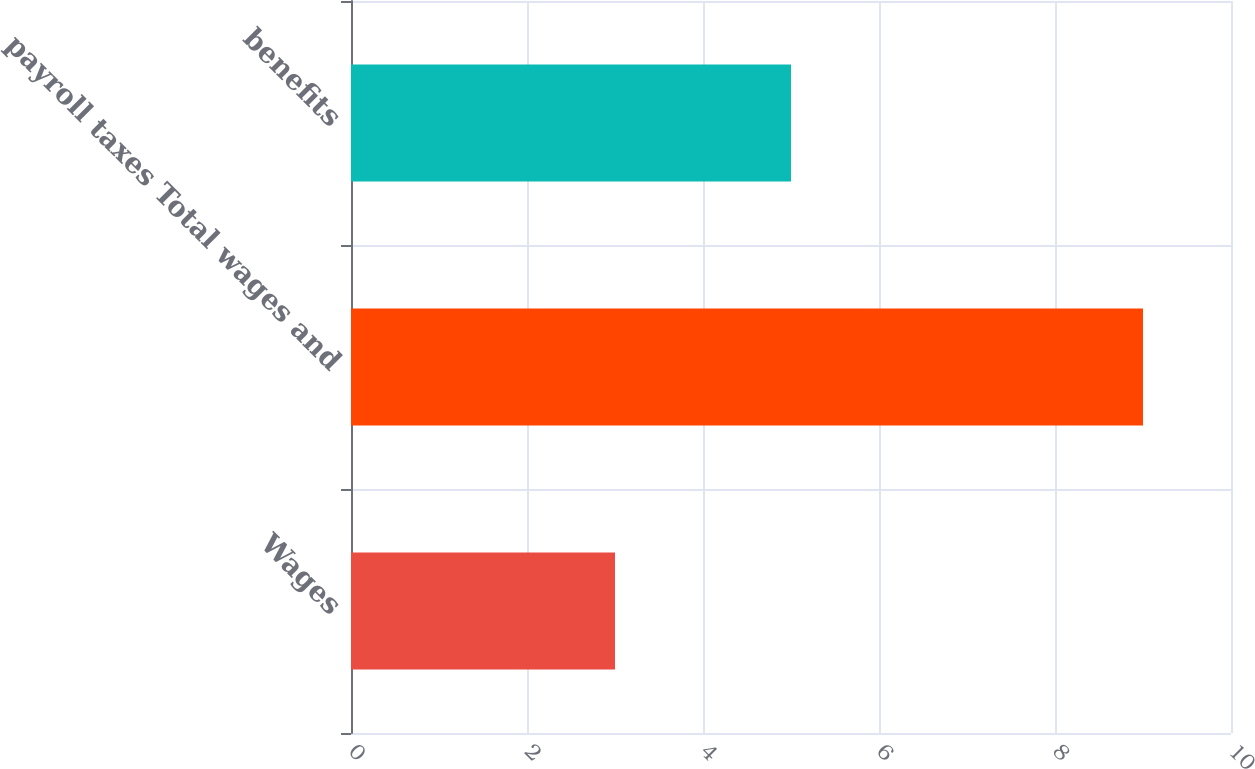<chart> <loc_0><loc_0><loc_500><loc_500><bar_chart><fcel>Wages<fcel>payroll taxes Total wages and<fcel>benefits<nl><fcel>3<fcel>9<fcel>5<nl></chart> 